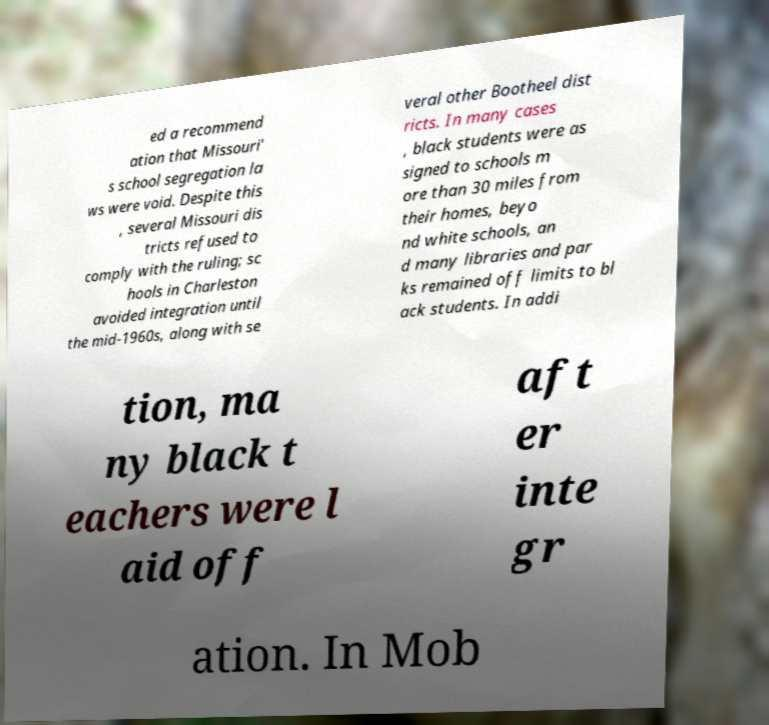There's text embedded in this image that I need extracted. Can you transcribe it verbatim? ed a recommend ation that Missouri' s school segregation la ws were void. Despite this , several Missouri dis tricts refused to comply with the ruling; sc hools in Charleston avoided integration until the mid-1960s, along with se veral other Bootheel dist ricts. In many cases , black students were as signed to schools m ore than 30 miles from their homes, beyo nd white schools, an d many libraries and par ks remained off limits to bl ack students. In addi tion, ma ny black t eachers were l aid off aft er inte gr ation. In Mob 